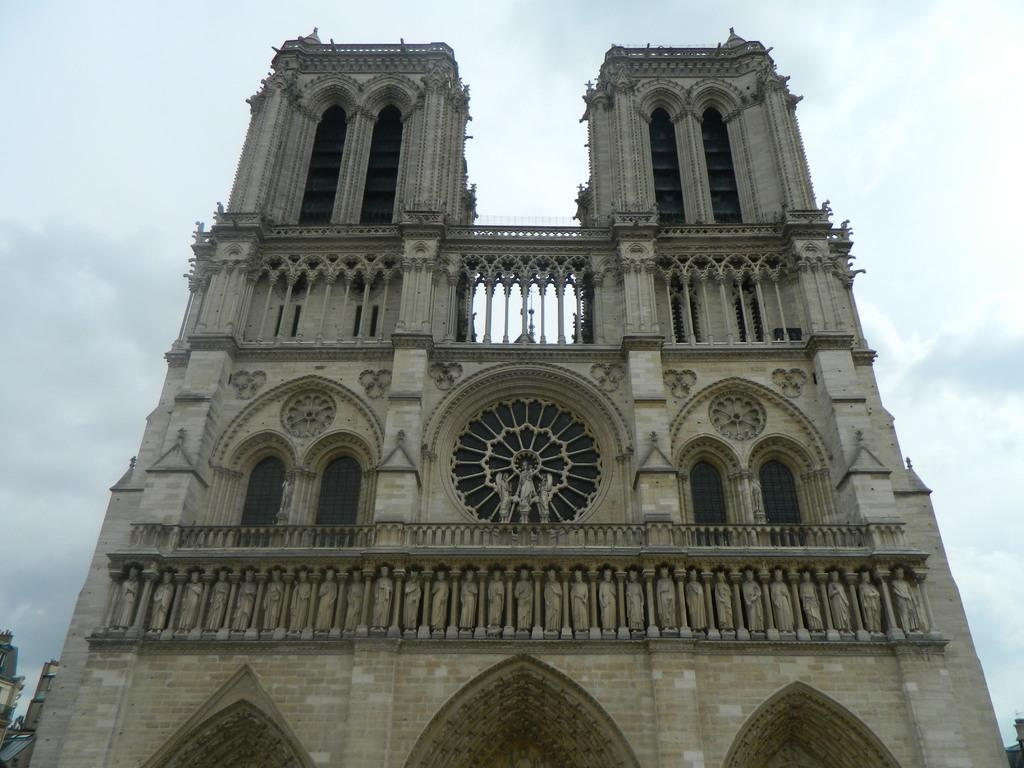What type of structure is present in the image? There is a building in the image. What colors can be seen on the building? The building has cream, brown, and black colors. Are there any decorative elements on the building? Yes, there are statues on the building. What can be seen in the distance behind the building? There are other buildings visible in the background, and the sky is also visible. Can you tell me what type of lettuce is growing on the building? There is no lettuce present on the building in the image. How does the camera capture the building in the image? The image does not show the process of capturing the building; it is a static representation of the building. 